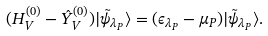Convert formula to latex. <formula><loc_0><loc_0><loc_500><loc_500>( H _ { V } ^ { ( 0 ) } - \hat { Y } _ { V } ^ { ( 0 ) } ) | \tilde { \psi } _ { \lambda _ { P } } \rangle = ( \epsilon _ { \lambda _ { P } } - \mu _ { P } ) | \tilde { \psi } _ { \lambda _ { P } } \rangle .</formula> 